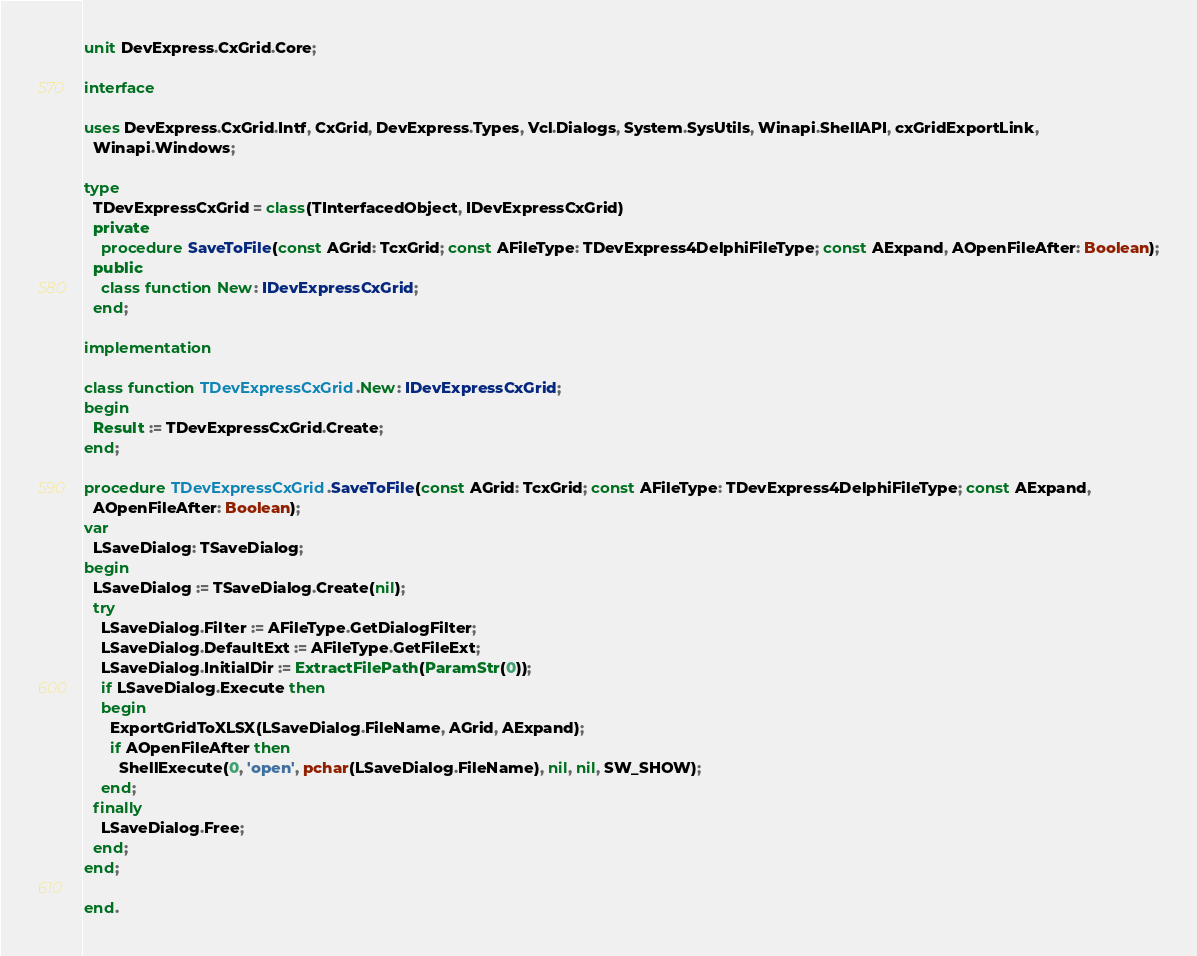<code> <loc_0><loc_0><loc_500><loc_500><_Pascal_>unit DevExpress.CxGrid.Core;

interface

uses DevExpress.CxGrid.Intf, CxGrid, DevExpress.Types, Vcl.Dialogs, System.SysUtils, Winapi.ShellAPI, cxGridExportLink,
  Winapi.Windows;

type
  TDevExpressCxGrid = class(TInterfacedObject, IDevExpressCxGrid)
  private
    procedure SaveToFile(const AGrid: TcxGrid; const AFileType: TDevExpress4DelphiFileType; const AExpand, AOpenFileAfter: Boolean);
  public
    class function New: IDevExpressCxGrid;
  end;

implementation

class function TDevExpressCxGrid.New: IDevExpressCxGrid;
begin
  Result := TDevExpressCxGrid.Create;
end;

procedure TDevExpressCxGrid.SaveToFile(const AGrid: TcxGrid; const AFileType: TDevExpress4DelphiFileType; const AExpand,
  AOpenFileAfter: Boolean);
var
  LSaveDialog: TSaveDialog;
begin
  LSaveDialog := TSaveDialog.Create(nil);
  try
    LSaveDialog.Filter := AFileType.GetDialogFilter;
    LSaveDialog.DefaultExt := AFileType.GetFileExt;
    LSaveDialog.InitialDir := ExtractFilePath(ParamStr(0));
    if LSaveDialog.Execute then
    begin
      ExportGridToXLSX(LSaveDialog.FileName, AGrid, AExpand);
      if AOpenFileAfter then
        ShellExecute(0, 'open', pchar(LSaveDialog.FileName), nil, nil, SW_SHOW);
    end;
  finally
    LSaveDialog.Free;
  end;
end;

end.
</code> 